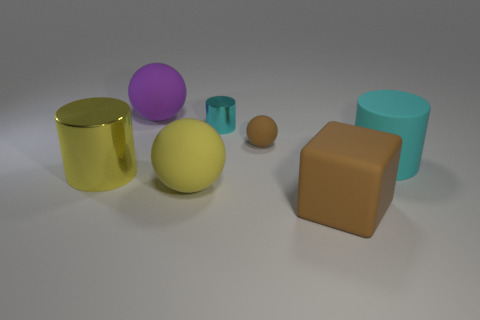Is the number of large yellow cylinders that are behind the big brown thing the same as the number of large cylinders that are left of the large purple thing? Upon examining the image, the count of large yellow cylinders positioned behind the sizeable brown object is indeed identical to the count of large cylinders situated to the left of the big purple sphere. Specifically, there is one large yellow cylinder behind the brown cube, and similarly, there is one large cyan cylinder to the left of the purple sphere, leading to the conclusion that the respective quantities are equal. 